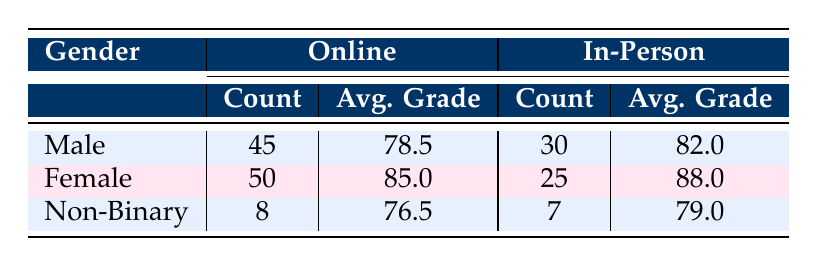What is the average grade of Male students in In-Person courses? The table shows that Male students in In-Person courses have an average grade of 82.0.
Answer: 82.0 How many Non-Binary students are enrolled in Online courses? According to the table, there are 8 Non-Binary students enrolled in Online courses.
Answer: 8 What is the total student count for Female students in both course types? To find the total for Female students, we add the counts: 50 (Online) + 25 (In-Person) = 75.
Answer: 75 Is the average grade of Female students higher than that of Male students in Online courses? Female students have an average grade of 85.0 while Male students have 78.5 in Online courses. Since 85.0 is greater than 78.5, the statement is true.
Answer: Yes What is the difference in average grades between Male and Female students in In-Person courses? Male students have an average grade of 82.0, and Female students have 88.0. The difference is calculated as 88.0 - 82.0 = 6.0.
Answer: 6.0 What is the total student count for all Non-Binary students? We sum the counts for Non-Binary students: 8 (Online) + 7 (In-Person) = 15.
Answer: 15 Do Male students perform better on average than Non-Binary students in Online courses? Male students have an average grade of 78.5 and Non-Binary students have 76.5. Since 78.5 is greater than 76.5, the statement is true.
Answer: Yes How many more Female students are in Online courses compared to In-Person courses? There are 50 Female students in Online courses and 25 in In-Person. Thus, the difference is 50 - 25 = 25.
Answer: 25 